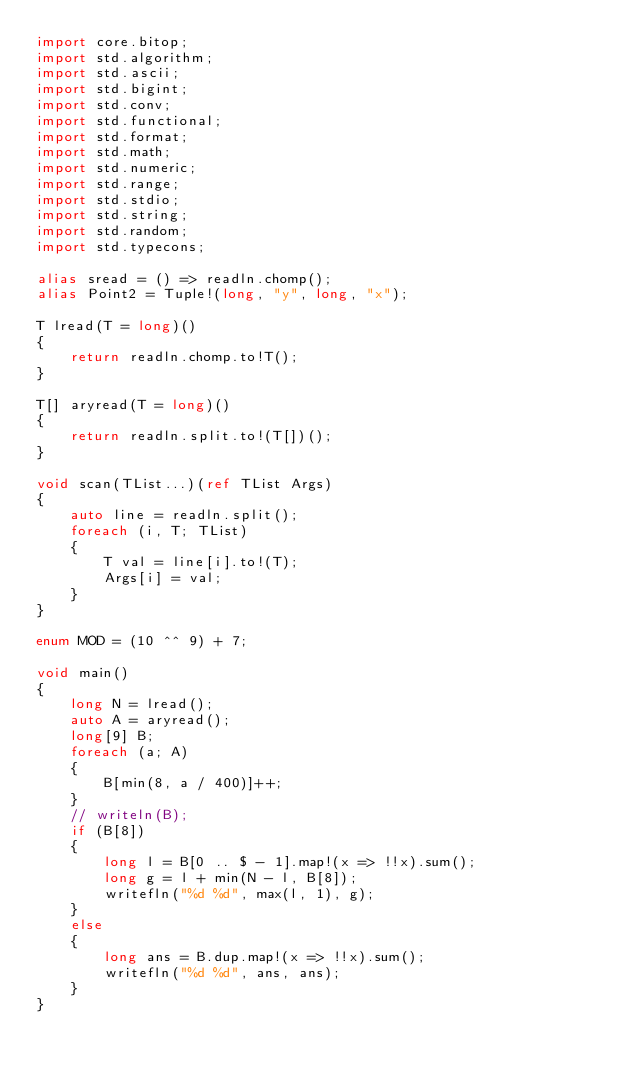Convert code to text. <code><loc_0><loc_0><loc_500><loc_500><_D_>import core.bitop;
import std.algorithm;
import std.ascii;
import std.bigint;
import std.conv;
import std.functional;
import std.format;
import std.math;
import std.numeric;
import std.range;
import std.stdio;
import std.string;
import std.random;
import std.typecons;

alias sread = () => readln.chomp();
alias Point2 = Tuple!(long, "y", long, "x");

T lread(T = long)()
{
    return readln.chomp.to!T();
}

T[] aryread(T = long)()
{
    return readln.split.to!(T[])();
}

void scan(TList...)(ref TList Args)
{
    auto line = readln.split();
    foreach (i, T; TList)
    {
        T val = line[i].to!(T);
        Args[i] = val;
    }
}

enum MOD = (10 ^^ 9) + 7;

void main()
{
    long N = lread();
    auto A = aryread();
    long[9] B;
    foreach (a; A)
    {
        B[min(8, a / 400)]++;
    }
    // writeln(B);
    if (B[8])
    {
        long l = B[0 .. $ - 1].map!(x => !!x).sum();
        long g = l + min(N - l, B[8]);
        writefln("%d %d", max(l, 1), g);
    }
    else
    {
        long ans = B.dup.map!(x => !!x).sum();
        writefln("%d %d", ans, ans);
    }
}
</code> 